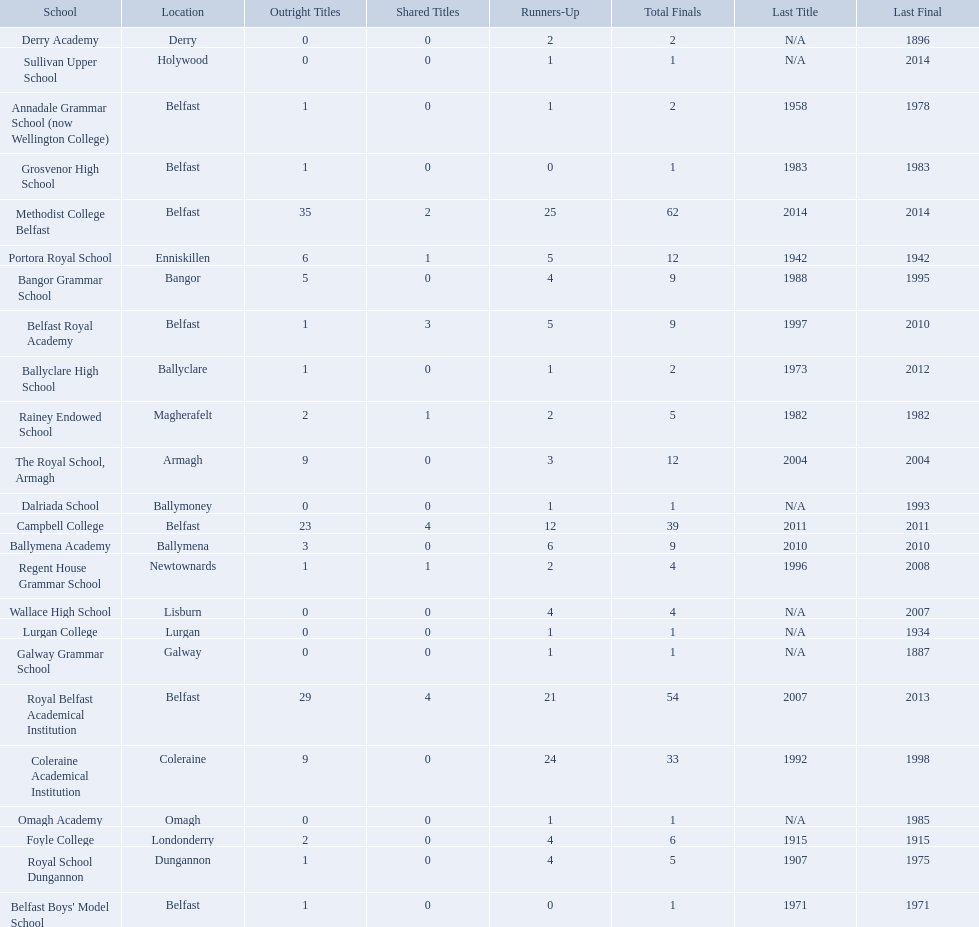How many schools are there? Methodist College Belfast, Royal Belfast Academical Institution, Campbell College, Coleraine Academical Institution, The Royal School, Armagh, Portora Royal School, Bangor Grammar School, Ballymena Academy, Rainey Endowed School, Foyle College, Belfast Royal Academy, Regent House Grammar School, Royal School Dungannon, Annadale Grammar School (now Wellington College), Ballyclare High School, Belfast Boys' Model School, Grosvenor High School, Wallace High School, Derry Academy, Dalriada School, Galway Grammar School, Lurgan College, Omagh Academy, Sullivan Upper School. How many outright titles does the coleraine academical institution have? 9. What other school has the same number of outright titles? The Royal School, Armagh. 